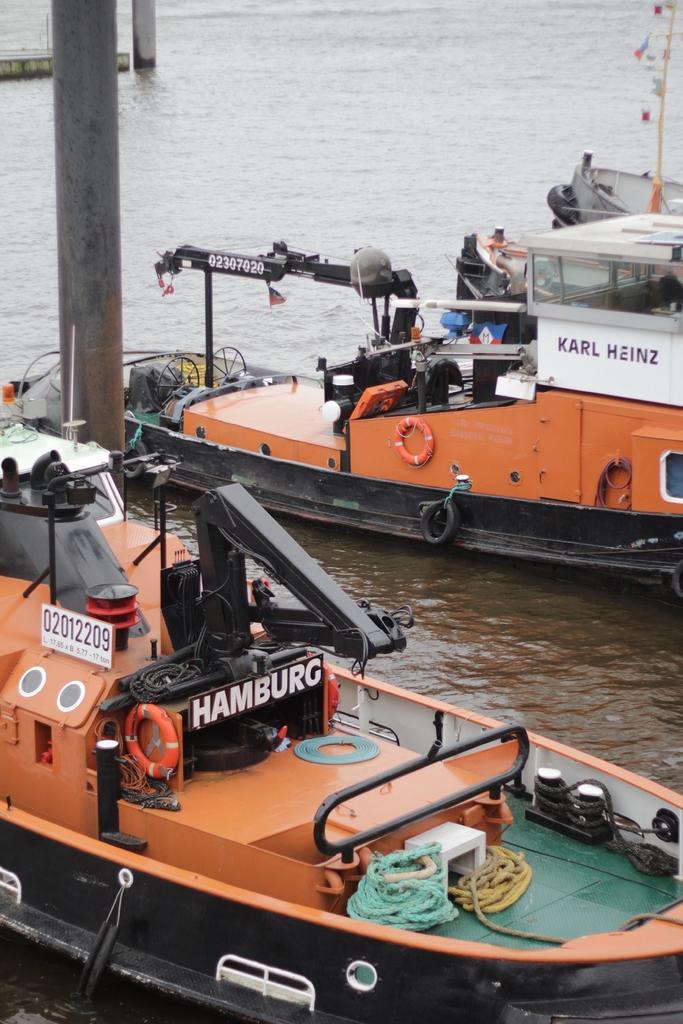Can you describe this image briefly? In this image we can see a few boats on the water, there are some ropes and other objects in the boats, also we can see the poles. 